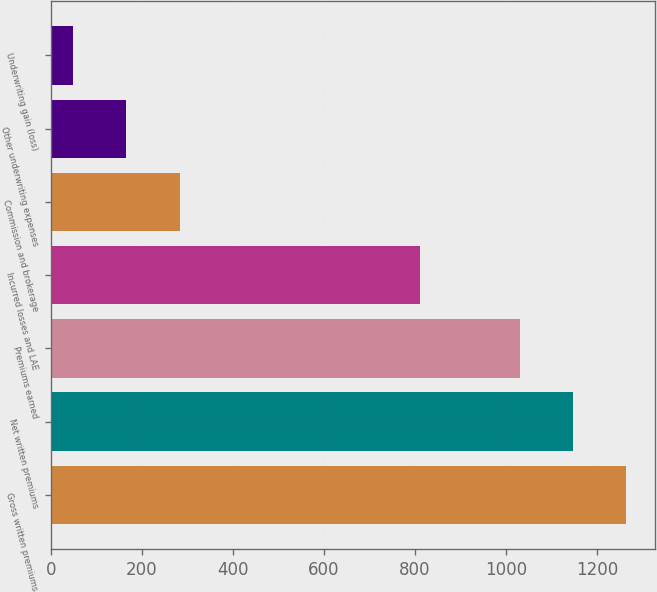Convert chart to OTSL. <chart><loc_0><loc_0><loc_500><loc_500><bar_chart><fcel>Gross written premiums<fcel>Net written premiums<fcel>Premiums earned<fcel>Incurred losses and LAE<fcel>Commission and brokerage<fcel>Other underwriting expenses<fcel>Underwriting gain (loss)<nl><fcel>1264.2<fcel>1147.25<fcel>1030.3<fcel>811.4<fcel>282.8<fcel>165.85<fcel>48.9<nl></chart> 